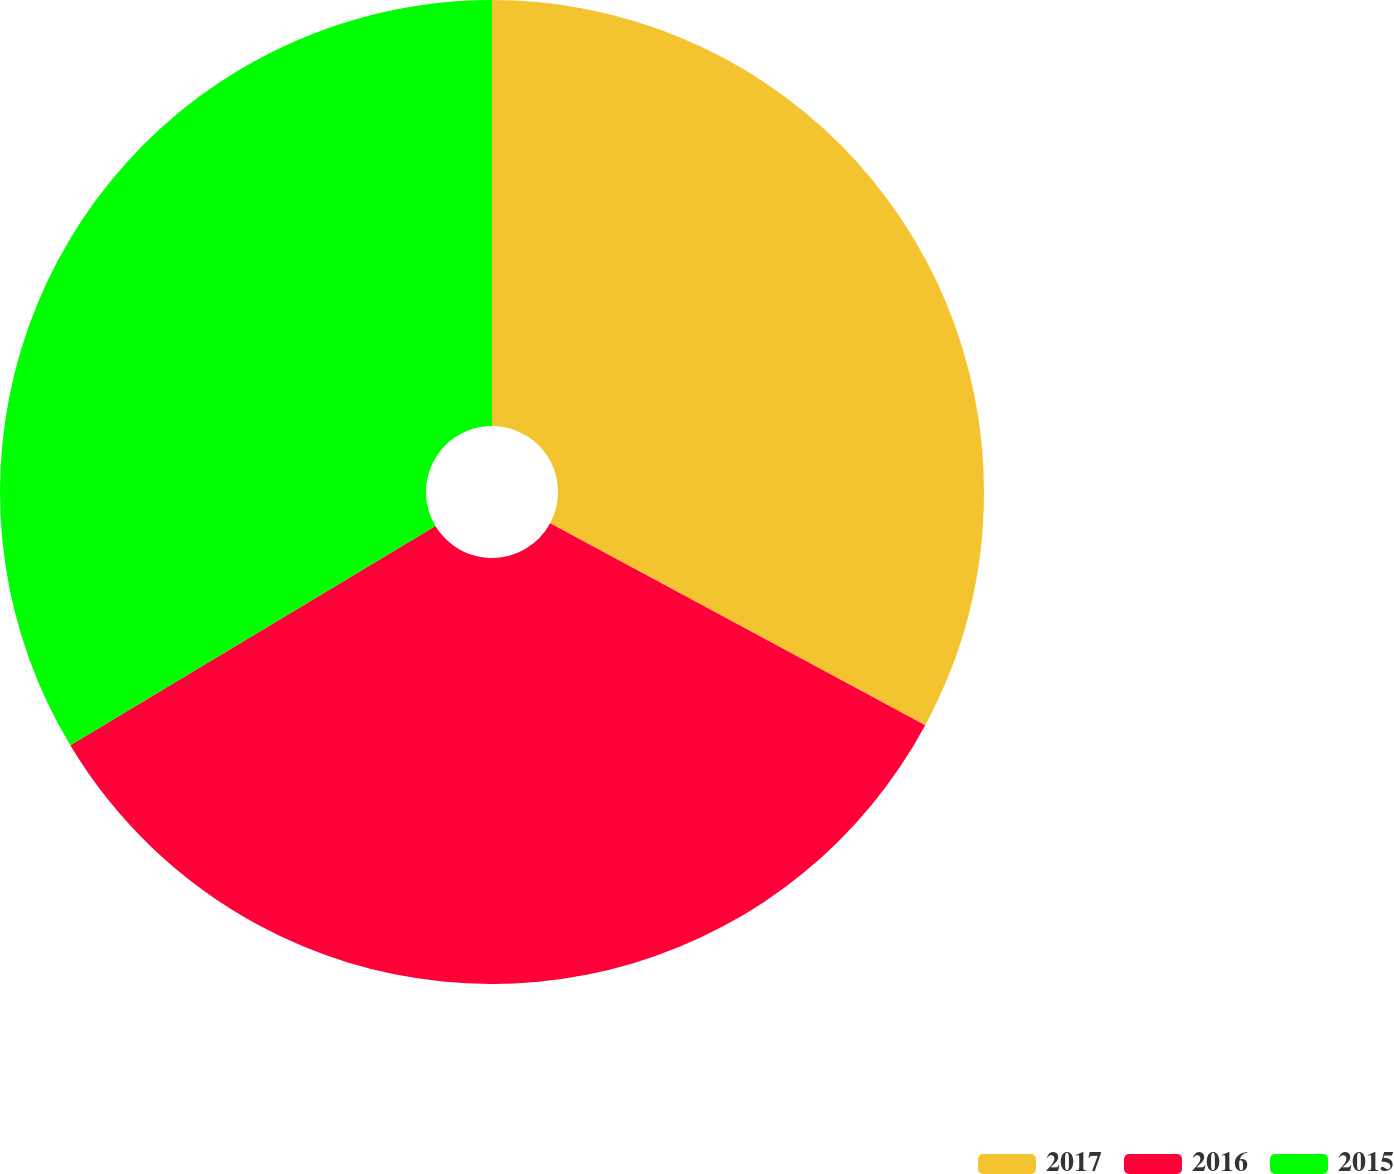Convert chart to OTSL. <chart><loc_0><loc_0><loc_500><loc_500><pie_chart><fcel>2017<fcel>2016<fcel>2015<nl><fcel>32.86%<fcel>33.53%<fcel>33.61%<nl></chart> 